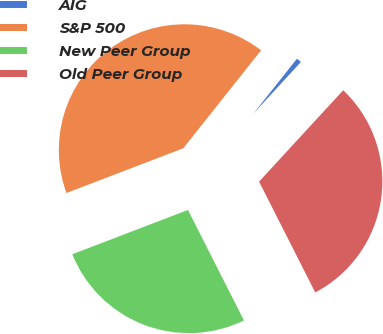<chart> <loc_0><loc_0><loc_500><loc_500><pie_chart><fcel>AIG<fcel>S&P 500<fcel>New Peer Group<fcel>Old Peer Group<nl><fcel>1.16%<fcel>41.5%<fcel>26.65%<fcel>30.69%<nl></chart> 